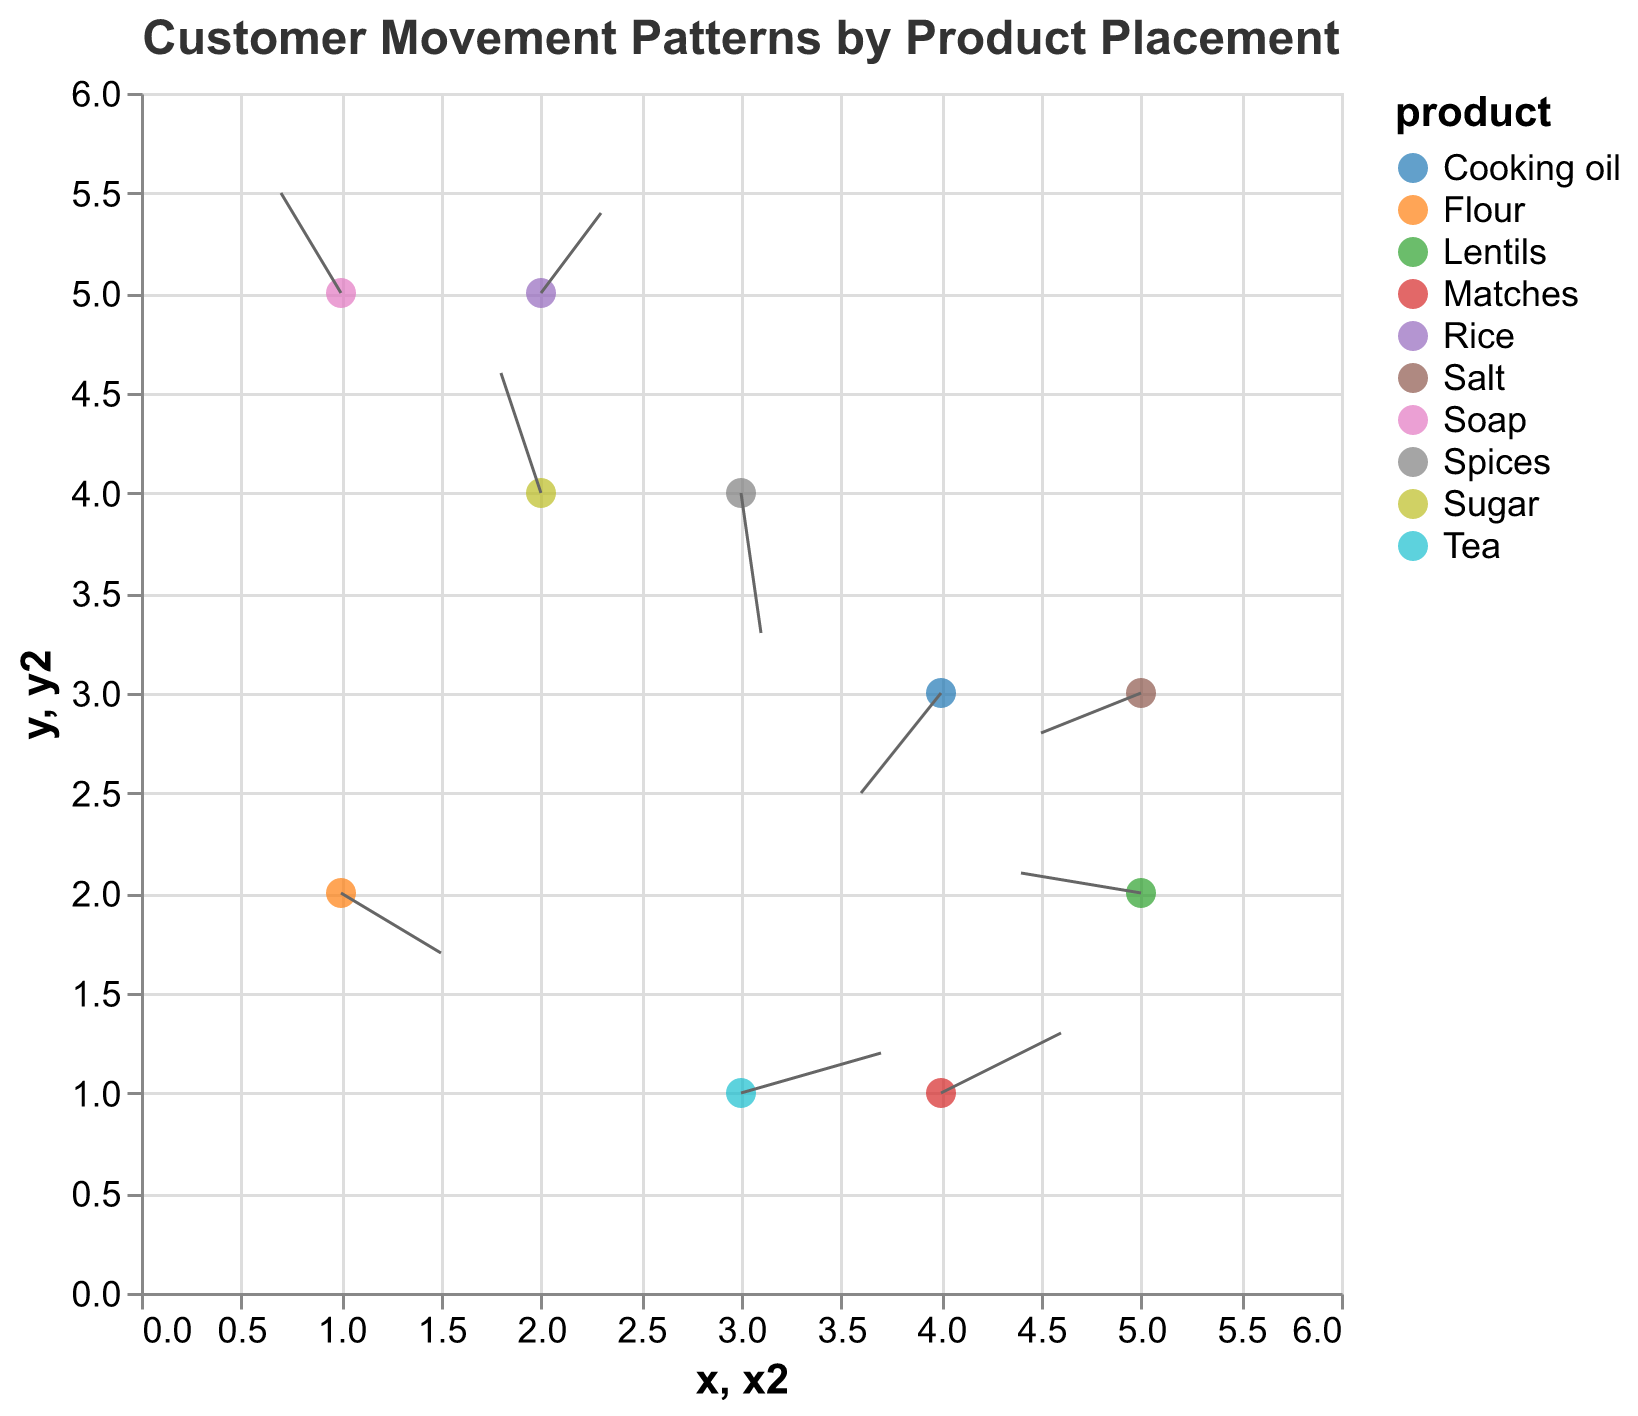What does the title of the figure indicate? The title of the figure is "Customer Movement Patterns by Product Placement." This indicates that the figure shows how customers move within the shop based on where different products are located.
Answer: Customer Movement Patterns by Product Placement How many different products are shown in the figure? The figure uses different colors to represent different products. Counting the unique colors or products listed in the tooltip, we can see there are 10 products displayed.
Answer: 10 Which product shows the largest horizontal movement to the right? The product with the largest positive value for "u" indicates the largest horizontal movement to the right. Looking at the data, "Tea" has the largest "u" value of 0.7.
Answer: Tea Which product is located at (1, 5)? The product at coordinates (1, 5) can be identified by checking the tooltip against these coordinates. The product located at (1, 5) is "Soap."
Answer: Soap What are the initial coordinates of the product "Lentils"? By checking the data for the product "Lentils," we find its initial coordinates are (5, 2).
Answer: (5, 2) What is the net vertical movement of "Sugar"? The net vertical movement can be determined by the value of "v" for "Sugar." According to the data, "Sugar" has a vertical movement "v" of 0.6.
Answer: 0.6 Compare the horizontal movement of "Salt" and "Cooking oil." Which one moves more to the left? The horizontal movement to the left is indicated by more negative values of "u." "Salt" has "u" of -0.5, while "Cooking oil" has "u" of -0.4. Therefore, "Salt" moves more to the left.
Answer: Salt What is the sum of the vertical movements of "Rice" and "Spices"? The vertical movements "v" for "Rice" and "Spices" are 0.4 and -0.7, respectively. Summing these up, 0.4 + (-0.7) = -0.3.
Answer: -0.3 Identify the product with the highest downward movement. The highest downward movement corresponds to the most negative "v" value. From the data, "Spices" has the most negative "v" value of -0.7.
Answer: Spices 